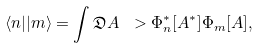Convert formula to latex. <formula><loc_0><loc_0><loc_500><loc_500>\langle n | | m \rangle = \int \mathfrak { D } A \ > \Phi _ { n } ^ { \ast } [ A ^ { \ast } ] \Phi _ { m } [ A ] ,</formula> 